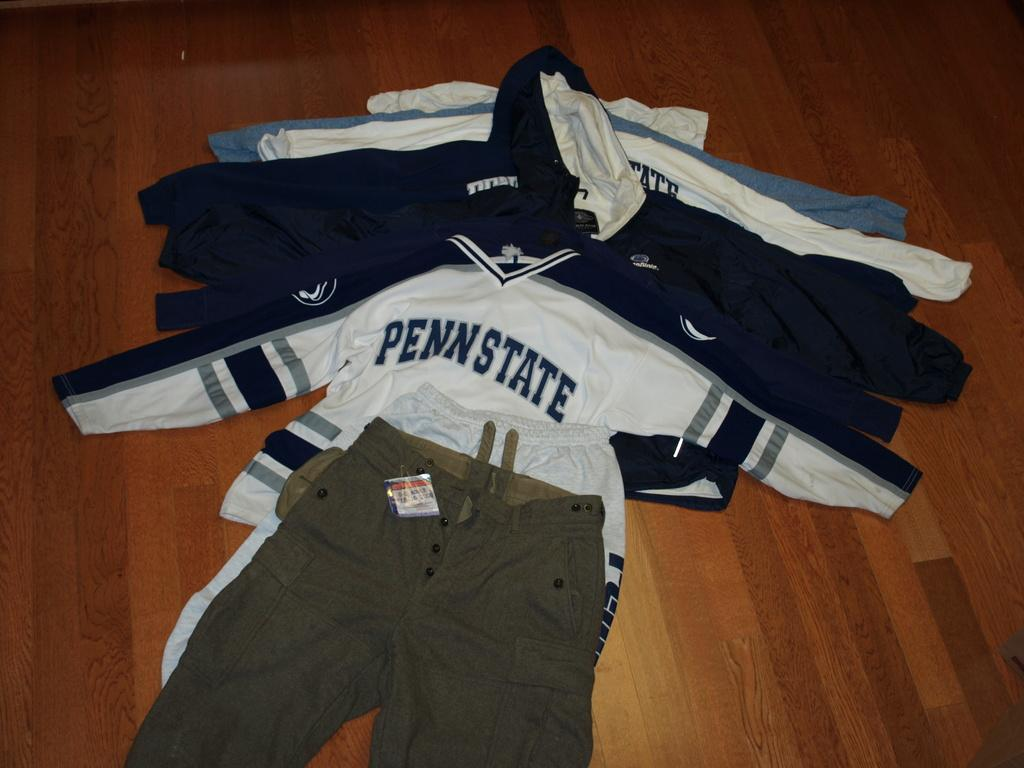<image>
Render a clear and concise summary of the photo. All the Penn State long-sleeved shirts are spread out underneath a pair of khaki cargo pants. 